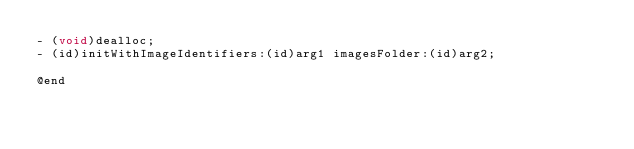<code> <loc_0><loc_0><loc_500><loc_500><_C_>- (void)dealloc;
- (id)initWithImageIdentifiers:(id)arg1 imagesFolder:(id)arg2;

@end

</code> 